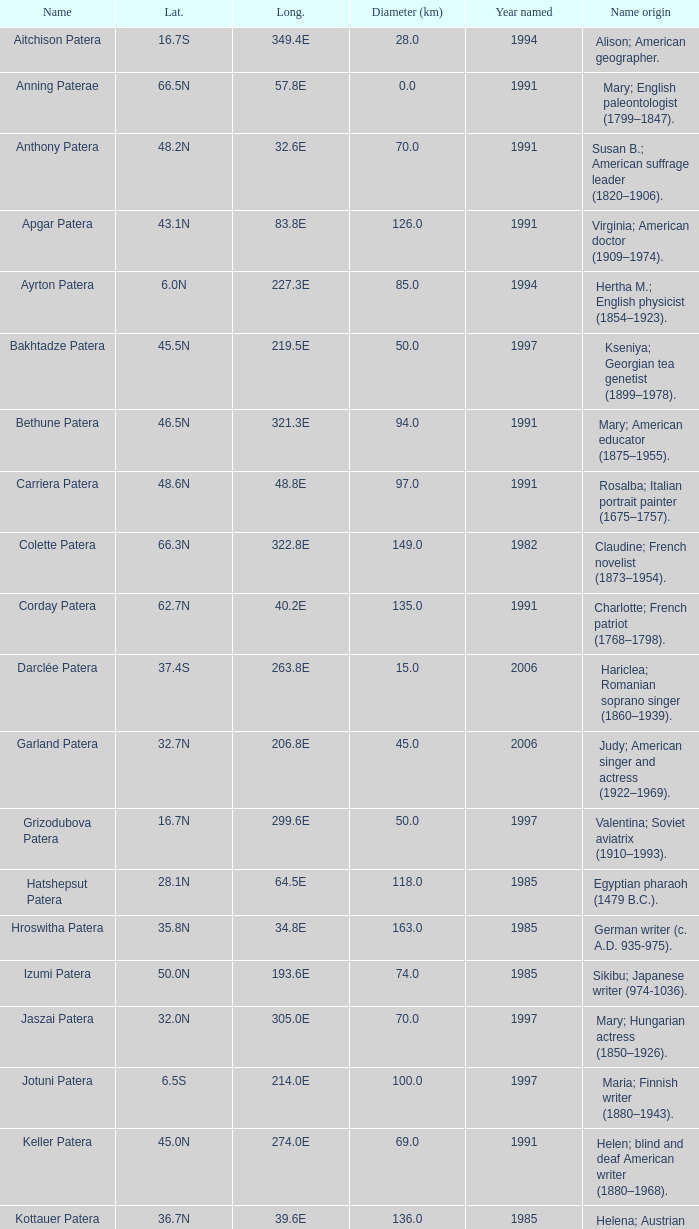What is  the diameter in km of the feature with a longitude of 40.2E?  135.0. Would you mind parsing the complete table? {'header': ['Name', 'Lat.', 'Long.', 'Diameter (km)', 'Year named', 'Name origin'], 'rows': [['Aitchison Patera', '16.7S', '349.4E', '28.0', '1994', 'Alison; American geographer.'], ['Anning Paterae', '66.5N', '57.8E', '0.0', '1991', 'Mary; English paleontologist (1799–1847).'], ['Anthony Patera', '48.2N', '32.6E', '70.0', '1991', 'Susan B.; American suffrage leader (1820–1906).'], ['Apgar Patera', '43.1N', '83.8E', '126.0', '1991', 'Virginia; American doctor (1909–1974).'], ['Ayrton Patera', '6.0N', '227.3E', '85.0', '1994', 'Hertha M.; English physicist (1854–1923).'], ['Bakhtadze Patera', '45.5N', '219.5E', '50.0', '1997', 'Kseniya; Georgian tea genetist (1899–1978).'], ['Bethune Patera', '46.5N', '321.3E', '94.0', '1991', 'Mary; American educator (1875–1955).'], ['Carriera Patera', '48.6N', '48.8E', '97.0', '1991', 'Rosalba; Italian portrait painter (1675–1757).'], ['Colette Patera', '66.3N', '322.8E', '149.0', '1982', 'Claudine; French novelist (1873–1954).'], ['Corday Patera', '62.7N', '40.2E', '135.0', '1991', 'Charlotte; French patriot (1768–1798).'], ['Darclée Patera', '37.4S', '263.8E', '15.0', '2006', 'Hariclea; Romanian soprano singer (1860–1939).'], ['Garland Patera', '32.7N', '206.8E', '45.0', '2006', 'Judy; American singer and actress (1922–1969).'], ['Grizodubova Patera', '16.7N', '299.6E', '50.0', '1997', 'Valentina; Soviet aviatrix (1910–1993).'], ['Hatshepsut Patera', '28.1N', '64.5E', '118.0', '1985', 'Egyptian pharaoh (1479 B.C.).'], ['Hroswitha Patera', '35.8N', '34.8E', '163.0', '1985', 'German writer (c. A.D. 935-975).'], ['Izumi Patera', '50.0N', '193.6E', '74.0', '1985', 'Sikibu; Japanese writer (974-1036).'], ['Jaszai Patera', '32.0N', '305.0E', '70.0', '1997', 'Mary; Hungarian actress (1850–1926).'], ['Jotuni Patera', '6.5S', '214.0E', '100.0', '1997', 'Maria; Finnish writer (1880–1943).'], ['Keller Patera', '45.0N', '274.0E', '69.0', '1991', 'Helen; blind and deaf American writer (1880–1968).'], ['Kottauer Patera', '36.7N', '39.6E', '136.0', '1985', 'Helena; Austrian historical writer (1410–1471).'], ['Kupo Patera', '41.9S', '195.5E', '100.0', '1997', 'Irena; Israelite astronomer (1929–1978).'], ['Ledoux Patera', '9.2S', '224.8E', '75.0', '1994', 'Jeanne; French artist (1767–1840).'], ['Lindgren Patera', '28.1N', '241.4E', '110.0', '2006', 'Astrid; Swedish author (1907–2002).'], ['Mehseti Patera', '16.0N', '311.0E', '60.0', '1997', 'Ganjevi; Azeri/Persian poet (c. 1050-c. 1100).'], ['Mezrina Patera', '33.3S', '68.8E', '60.0', '2000', 'Anna; Russian clay toy sculptor (1853–1938).'], ['Nordenflycht Patera', '35.0S', '266.0E', '140.0', '1997', 'Hedwig; Swedish poet (1718–1763).'], ['Panina Patera', '13.0S', '309.8E', '50.0', '1997', 'Varya; Gypsy/Russian singer (1872–1911).'], ['Payne-Gaposchkin Patera', '25.5S', '196.0E', '100.0', '1997', 'Cecilia Helena; American astronomer (1900–1979).'], ['Pocahontas Patera', '64.9N', '49.4E', '78.0', '1991', 'Powhatan Indian peacemaker (1595–1617).'], ['Raskova Paterae', '51.0S', '222.8E', '80.0', '1994', 'Marina M.; Russian aviator (1912–1943).'], ['Razia Patera', '46.2N', '197.8E', '157.0', '1985', 'Queen of Delhi Sultanate (India) (1236–1240).'], ['Shulzhenko Patera', '6.5N', '264.5E', '60.0', '1997', 'Klavdiya; Soviet singer (1906–1984).'], ['Siddons Patera', '61.6N', '340.6E', '47.0', '1997', 'Sarah; English actress (1755–1831).'], ['Stopes Patera', '42.6N', '46.5E', '169.0', '1991', 'Marie; English paleontologist (1880–1959).'], ['Tarbell Patera', '58.2S', '351.5E', '80.0', '1994', 'Ida; American author, editor (1857–1944).'], ['Teasdale Patera', '67.6S', '189.1E', '75.0', '1994', 'Sara; American poet (1884–1933).'], ['Tey Patera', '17.8S', '349.1E', '20.0', '1994', 'Josephine; Scottish author (1897–1952).'], ['Tipporah Patera', '38.9N', '43.0E', '99.0', '1985', 'Hebrew medical scholar (1500 B.C.).'], ['Vibert-Douglas Patera', '11.6S', '194.3E', '45.0', '2003', 'Allie; Canadian astronomer (1894–1988).'], ['Villepreux-Power Patera', '22.0S', '210.0E', '100.0', '1997', 'Jeannette; French marine biologist (1794–1871).'], ['Wilde Patera', '21.3S', '266.3E', '75.0', '2000', 'Lady Jane Francesca; Irish poet (1821–1891).'], ['Witte Patera', '25.8S', '247.65E', '35.0', '2006', 'Wilhelmine; German astronomer (1777–1854).'], ['Woodhull Patera', '37.4N', '305.4E', '83.0', '1991', 'Victoria; American-English lecturer (1838–1927).']]} 